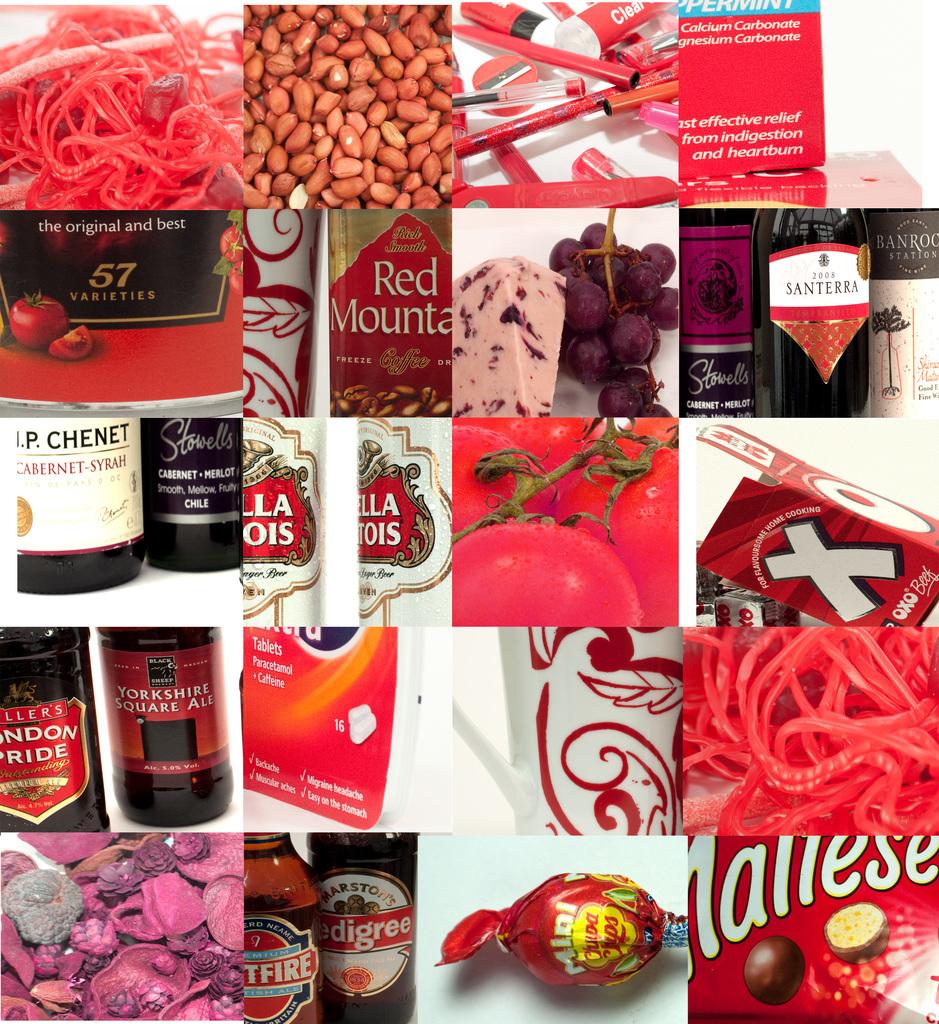What is the beer called at the bottom?
Make the answer very short. Pedigree. How many varieties are there of the product in the top left area?
Provide a succinct answer. 57. 